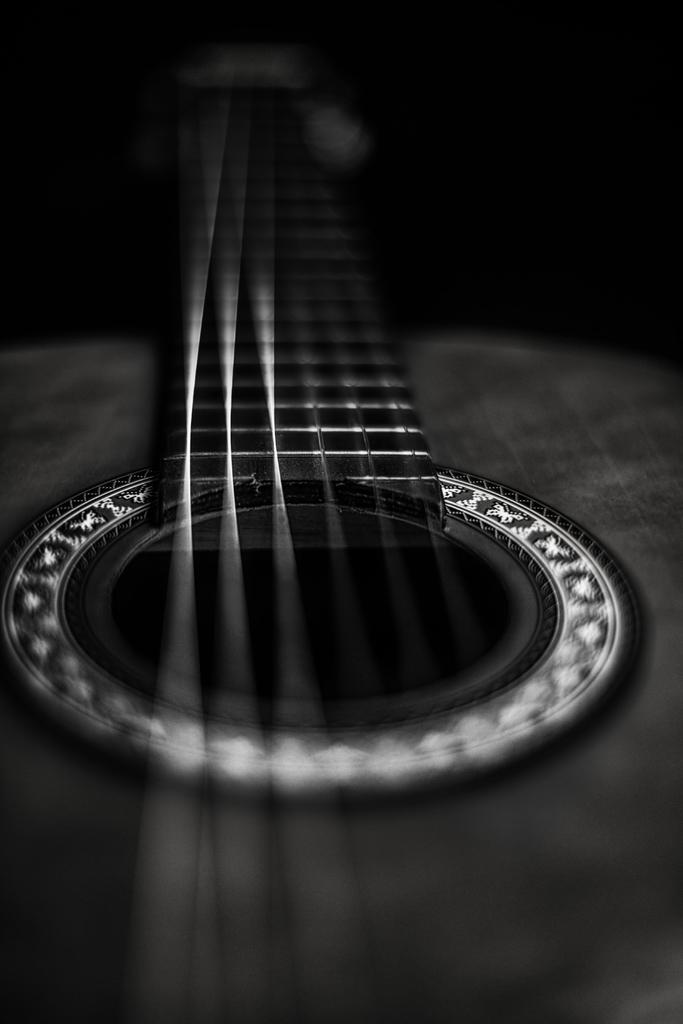What type of instrument is in the image? There is a gray color guitar in the image. How many strings does the guitar have? The guitar has 6 strings. Can you describe any specific details about the guitar's appearance? There is a silver line on the guitar. What type of silk material is draped over the guitar in the image? There is no silk material draped over the guitar in the image. How do the bushes surrounding the guitar in the image affect its sound? There are no bushes present in the image, so their effect on the guitar's sound cannot be determined. 